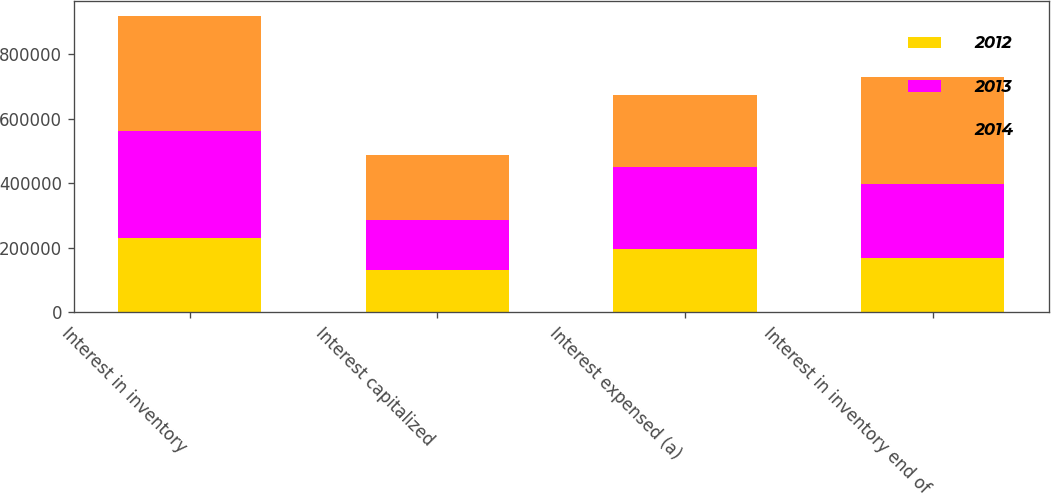Convert chart. <chart><loc_0><loc_0><loc_500><loc_500><stacked_bar_chart><ecel><fcel>Interest in inventory<fcel>Interest capitalized<fcel>Interest expensed (a)<fcel>Interest in inventory end of<nl><fcel>2012<fcel>230922<fcel>131444<fcel>194728<fcel>167638<nl><fcel>2013<fcel>331880<fcel>154107<fcel>255065<fcel>230922<nl><fcel>2014<fcel>355068<fcel>201103<fcel>224291<fcel>331880<nl></chart> 